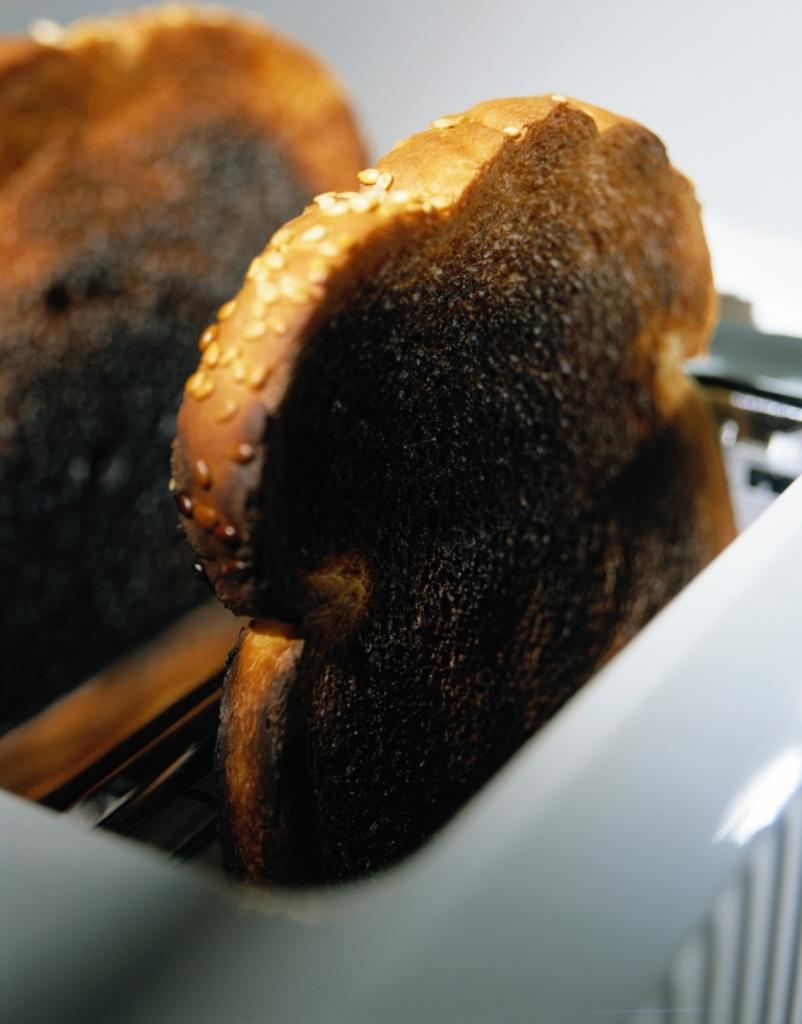What type of food can be seen in the image? There are toasted breads in the image. What can be found on the surface of the toasted breads? Sesame seeds are present in the image. What appliance is visible in the image? There is a toaster in the image. What is the distance between the toasted breads and the plane in the image? There is no plane present in the image, so it is not possible to determine the distance between the toasted breads and a plane. 